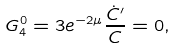<formula> <loc_0><loc_0><loc_500><loc_500>G ^ { 0 } _ { 4 } = 3 e ^ { - 2 \mu } \frac { \dot { C } ^ { \prime } } { C } = 0 ,</formula> 